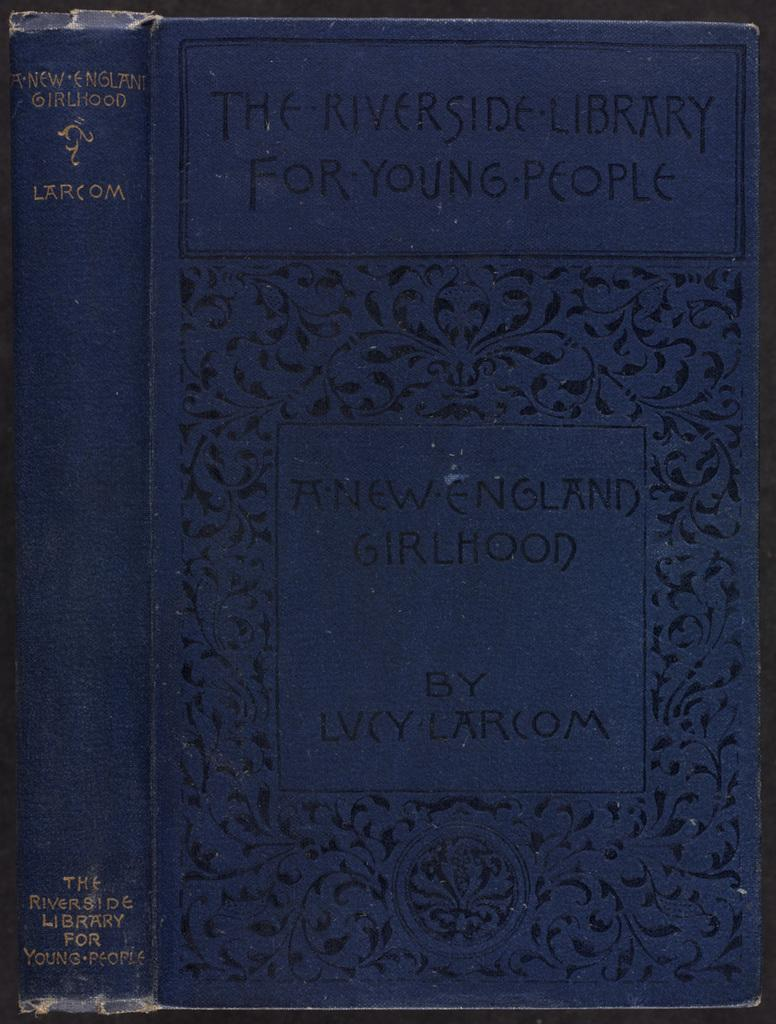<image>
Share a concise interpretation of the image provided. A copy of New England Girlhood by Lucy Larcom is at the Riverside Library for Young People. 